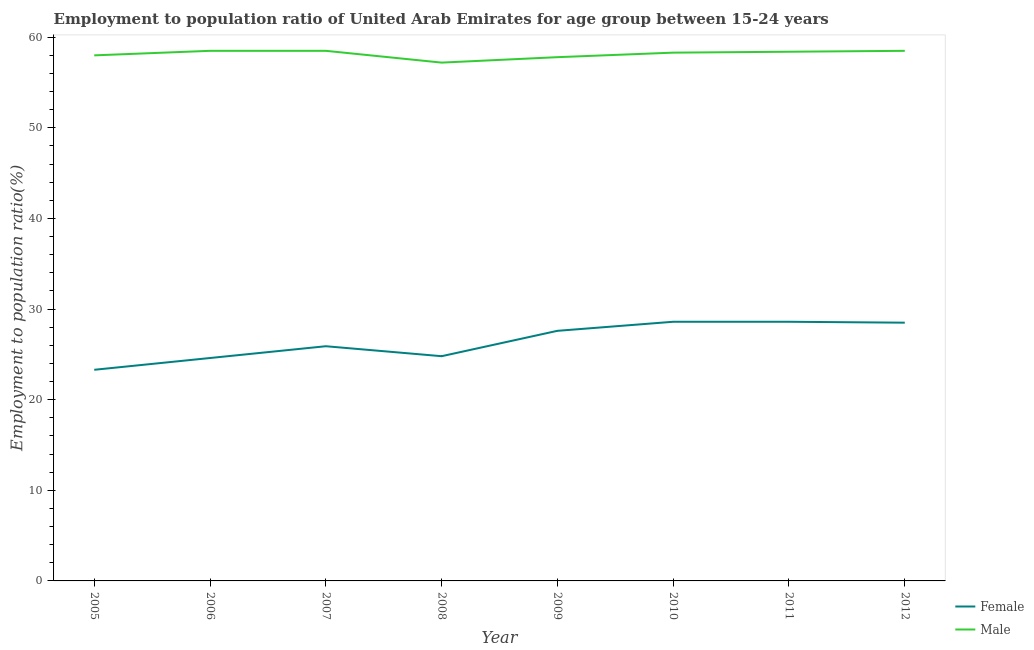How many different coloured lines are there?
Your answer should be very brief. 2. Does the line corresponding to employment to population ratio(female) intersect with the line corresponding to employment to population ratio(male)?
Make the answer very short. No. Across all years, what is the maximum employment to population ratio(male)?
Offer a terse response. 58.5. Across all years, what is the minimum employment to population ratio(female)?
Offer a terse response. 23.3. In which year was the employment to population ratio(male) minimum?
Ensure brevity in your answer.  2008. What is the total employment to population ratio(male) in the graph?
Make the answer very short. 465.2. What is the difference between the employment to population ratio(male) in 2009 and that in 2011?
Your answer should be compact. -0.6. What is the difference between the employment to population ratio(female) in 2006 and the employment to population ratio(male) in 2008?
Your answer should be compact. -32.6. What is the average employment to population ratio(female) per year?
Provide a short and direct response. 26.49. What is the ratio of the employment to population ratio(male) in 2008 to that in 2010?
Your answer should be compact. 0.98. Is the employment to population ratio(male) in 2010 less than that in 2012?
Provide a succinct answer. Yes. What is the difference between the highest and the lowest employment to population ratio(male)?
Keep it short and to the point. 1.3. In how many years, is the employment to population ratio(male) greater than the average employment to population ratio(male) taken over all years?
Offer a terse response. 5. Is the sum of the employment to population ratio(male) in 2009 and 2010 greater than the maximum employment to population ratio(female) across all years?
Your answer should be very brief. Yes. Does the employment to population ratio(female) monotonically increase over the years?
Your answer should be very brief. No. Is the employment to population ratio(male) strictly less than the employment to population ratio(female) over the years?
Make the answer very short. No. How many lines are there?
Your response must be concise. 2. How many years are there in the graph?
Offer a very short reply. 8. Does the graph contain grids?
Provide a short and direct response. No. How many legend labels are there?
Provide a short and direct response. 2. What is the title of the graph?
Your response must be concise. Employment to population ratio of United Arab Emirates for age group between 15-24 years. What is the label or title of the X-axis?
Provide a short and direct response. Year. What is the Employment to population ratio(%) of Female in 2005?
Your answer should be compact. 23.3. What is the Employment to population ratio(%) of Male in 2005?
Offer a terse response. 58. What is the Employment to population ratio(%) in Female in 2006?
Give a very brief answer. 24.6. What is the Employment to population ratio(%) in Male in 2006?
Make the answer very short. 58.5. What is the Employment to population ratio(%) in Female in 2007?
Provide a short and direct response. 25.9. What is the Employment to population ratio(%) in Male in 2007?
Your response must be concise. 58.5. What is the Employment to population ratio(%) of Female in 2008?
Provide a short and direct response. 24.8. What is the Employment to population ratio(%) of Male in 2008?
Offer a terse response. 57.2. What is the Employment to population ratio(%) in Female in 2009?
Provide a short and direct response. 27.6. What is the Employment to population ratio(%) of Male in 2009?
Your answer should be very brief. 57.8. What is the Employment to population ratio(%) of Female in 2010?
Make the answer very short. 28.6. What is the Employment to population ratio(%) in Male in 2010?
Give a very brief answer. 58.3. What is the Employment to population ratio(%) of Female in 2011?
Your answer should be compact. 28.6. What is the Employment to population ratio(%) in Male in 2011?
Provide a short and direct response. 58.4. What is the Employment to population ratio(%) of Female in 2012?
Provide a short and direct response. 28.5. What is the Employment to population ratio(%) in Male in 2012?
Your response must be concise. 58.5. Across all years, what is the maximum Employment to population ratio(%) in Female?
Make the answer very short. 28.6. Across all years, what is the maximum Employment to population ratio(%) of Male?
Ensure brevity in your answer.  58.5. Across all years, what is the minimum Employment to population ratio(%) in Female?
Make the answer very short. 23.3. Across all years, what is the minimum Employment to population ratio(%) in Male?
Offer a very short reply. 57.2. What is the total Employment to population ratio(%) of Female in the graph?
Provide a short and direct response. 211.9. What is the total Employment to population ratio(%) in Male in the graph?
Make the answer very short. 465.2. What is the difference between the Employment to population ratio(%) of Male in 2005 and that in 2006?
Give a very brief answer. -0.5. What is the difference between the Employment to population ratio(%) of Male in 2005 and that in 2007?
Your response must be concise. -0.5. What is the difference between the Employment to population ratio(%) of Female in 2005 and that in 2009?
Give a very brief answer. -4.3. What is the difference between the Employment to population ratio(%) in Male in 2005 and that in 2009?
Make the answer very short. 0.2. What is the difference between the Employment to population ratio(%) of Female in 2005 and that in 2010?
Provide a succinct answer. -5.3. What is the difference between the Employment to population ratio(%) of Female in 2005 and that in 2012?
Make the answer very short. -5.2. What is the difference between the Employment to population ratio(%) in Male in 2006 and that in 2007?
Give a very brief answer. 0. What is the difference between the Employment to population ratio(%) in Female in 2006 and that in 2010?
Make the answer very short. -4. What is the difference between the Employment to population ratio(%) in Male in 2006 and that in 2010?
Your response must be concise. 0.2. What is the difference between the Employment to population ratio(%) in Female in 2006 and that in 2011?
Offer a terse response. -4. What is the difference between the Employment to population ratio(%) in Male in 2006 and that in 2011?
Offer a very short reply. 0.1. What is the difference between the Employment to population ratio(%) of Female in 2007 and that in 2008?
Your response must be concise. 1.1. What is the difference between the Employment to population ratio(%) in Male in 2007 and that in 2008?
Offer a terse response. 1.3. What is the difference between the Employment to population ratio(%) of Male in 2007 and that in 2009?
Provide a succinct answer. 0.7. What is the difference between the Employment to population ratio(%) in Male in 2007 and that in 2011?
Ensure brevity in your answer.  0.1. What is the difference between the Employment to population ratio(%) of Female in 2008 and that in 2009?
Your response must be concise. -2.8. What is the difference between the Employment to population ratio(%) of Female in 2008 and that in 2010?
Provide a succinct answer. -3.8. What is the difference between the Employment to population ratio(%) in Male in 2008 and that in 2010?
Keep it short and to the point. -1.1. What is the difference between the Employment to population ratio(%) in Female in 2008 and that in 2011?
Keep it short and to the point. -3.8. What is the difference between the Employment to population ratio(%) in Female in 2008 and that in 2012?
Your answer should be compact. -3.7. What is the difference between the Employment to population ratio(%) of Female in 2009 and that in 2010?
Ensure brevity in your answer.  -1. What is the difference between the Employment to population ratio(%) of Female in 2009 and that in 2011?
Your answer should be compact. -1. What is the difference between the Employment to population ratio(%) in Male in 2009 and that in 2011?
Your response must be concise. -0.6. What is the difference between the Employment to population ratio(%) of Female in 2009 and that in 2012?
Ensure brevity in your answer.  -0.9. What is the difference between the Employment to population ratio(%) in Female in 2010 and that in 2011?
Your response must be concise. 0. What is the difference between the Employment to population ratio(%) in Female in 2010 and that in 2012?
Provide a short and direct response. 0.1. What is the difference between the Employment to population ratio(%) in Male in 2010 and that in 2012?
Provide a short and direct response. -0.2. What is the difference between the Employment to population ratio(%) of Female in 2011 and that in 2012?
Give a very brief answer. 0.1. What is the difference between the Employment to population ratio(%) of Male in 2011 and that in 2012?
Make the answer very short. -0.1. What is the difference between the Employment to population ratio(%) in Female in 2005 and the Employment to population ratio(%) in Male in 2006?
Make the answer very short. -35.2. What is the difference between the Employment to population ratio(%) of Female in 2005 and the Employment to population ratio(%) of Male in 2007?
Your response must be concise. -35.2. What is the difference between the Employment to population ratio(%) of Female in 2005 and the Employment to population ratio(%) of Male in 2008?
Offer a terse response. -33.9. What is the difference between the Employment to population ratio(%) of Female in 2005 and the Employment to population ratio(%) of Male in 2009?
Make the answer very short. -34.5. What is the difference between the Employment to population ratio(%) of Female in 2005 and the Employment to population ratio(%) of Male in 2010?
Give a very brief answer. -35. What is the difference between the Employment to population ratio(%) in Female in 2005 and the Employment to population ratio(%) in Male in 2011?
Give a very brief answer. -35.1. What is the difference between the Employment to population ratio(%) in Female in 2005 and the Employment to population ratio(%) in Male in 2012?
Give a very brief answer. -35.2. What is the difference between the Employment to population ratio(%) in Female in 2006 and the Employment to population ratio(%) in Male in 2007?
Make the answer very short. -33.9. What is the difference between the Employment to population ratio(%) in Female in 2006 and the Employment to population ratio(%) in Male in 2008?
Make the answer very short. -32.6. What is the difference between the Employment to population ratio(%) of Female in 2006 and the Employment to population ratio(%) of Male in 2009?
Offer a terse response. -33.2. What is the difference between the Employment to population ratio(%) of Female in 2006 and the Employment to population ratio(%) of Male in 2010?
Ensure brevity in your answer.  -33.7. What is the difference between the Employment to population ratio(%) of Female in 2006 and the Employment to population ratio(%) of Male in 2011?
Give a very brief answer. -33.8. What is the difference between the Employment to population ratio(%) in Female in 2006 and the Employment to population ratio(%) in Male in 2012?
Offer a terse response. -33.9. What is the difference between the Employment to population ratio(%) of Female in 2007 and the Employment to population ratio(%) of Male in 2008?
Offer a very short reply. -31.3. What is the difference between the Employment to population ratio(%) of Female in 2007 and the Employment to population ratio(%) of Male in 2009?
Give a very brief answer. -31.9. What is the difference between the Employment to population ratio(%) in Female in 2007 and the Employment to population ratio(%) in Male in 2010?
Keep it short and to the point. -32.4. What is the difference between the Employment to population ratio(%) of Female in 2007 and the Employment to population ratio(%) of Male in 2011?
Offer a terse response. -32.5. What is the difference between the Employment to population ratio(%) of Female in 2007 and the Employment to population ratio(%) of Male in 2012?
Your answer should be compact. -32.6. What is the difference between the Employment to population ratio(%) in Female in 2008 and the Employment to population ratio(%) in Male in 2009?
Ensure brevity in your answer.  -33. What is the difference between the Employment to population ratio(%) in Female in 2008 and the Employment to population ratio(%) in Male in 2010?
Make the answer very short. -33.5. What is the difference between the Employment to population ratio(%) in Female in 2008 and the Employment to population ratio(%) in Male in 2011?
Offer a terse response. -33.6. What is the difference between the Employment to population ratio(%) in Female in 2008 and the Employment to population ratio(%) in Male in 2012?
Your answer should be compact. -33.7. What is the difference between the Employment to population ratio(%) in Female in 2009 and the Employment to population ratio(%) in Male in 2010?
Give a very brief answer. -30.7. What is the difference between the Employment to population ratio(%) in Female in 2009 and the Employment to population ratio(%) in Male in 2011?
Your answer should be very brief. -30.8. What is the difference between the Employment to population ratio(%) in Female in 2009 and the Employment to population ratio(%) in Male in 2012?
Offer a terse response. -30.9. What is the difference between the Employment to population ratio(%) in Female in 2010 and the Employment to population ratio(%) in Male in 2011?
Provide a succinct answer. -29.8. What is the difference between the Employment to population ratio(%) in Female in 2010 and the Employment to population ratio(%) in Male in 2012?
Provide a succinct answer. -29.9. What is the difference between the Employment to population ratio(%) of Female in 2011 and the Employment to population ratio(%) of Male in 2012?
Give a very brief answer. -29.9. What is the average Employment to population ratio(%) of Female per year?
Offer a terse response. 26.49. What is the average Employment to population ratio(%) in Male per year?
Ensure brevity in your answer.  58.15. In the year 2005, what is the difference between the Employment to population ratio(%) in Female and Employment to population ratio(%) in Male?
Give a very brief answer. -34.7. In the year 2006, what is the difference between the Employment to population ratio(%) of Female and Employment to population ratio(%) of Male?
Your answer should be compact. -33.9. In the year 2007, what is the difference between the Employment to population ratio(%) of Female and Employment to population ratio(%) of Male?
Offer a very short reply. -32.6. In the year 2008, what is the difference between the Employment to population ratio(%) in Female and Employment to population ratio(%) in Male?
Give a very brief answer. -32.4. In the year 2009, what is the difference between the Employment to population ratio(%) in Female and Employment to population ratio(%) in Male?
Your answer should be compact. -30.2. In the year 2010, what is the difference between the Employment to population ratio(%) in Female and Employment to population ratio(%) in Male?
Your answer should be compact. -29.7. In the year 2011, what is the difference between the Employment to population ratio(%) of Female and Employment to population ratio(%) of Male?
Keep it short and to the point. -29.8. What is the ratio of the Employment to population ratio(%) in Female in 2005 to that in 2006?
Give a very brief answer. 0.95. What is the ratio of the Employment to population ratio(%) of Female in 2005 to that in 2007?
Provide a succinct answer. 0.9. What is the ratio of the Employment to population ratio(%) of Female in 2005 to that in 2008?
Your answer should be very brief. 0.94. What is the ratio of the Employment to population ratio(%) in Male in 2005 to that in 2008?
Offer a very short reply. 1.01. What is the ratio of the Employment to population ratio(%) of Female in 2005 to that in 2009?
Give a very brief answer. 0.84. What is the ratio of the Employment to population ratio(%) in Female in 2005 to that in 2010?
Ensure brevity in your answer.  0.81. What is the ratio of the Employment to population ratio(%) of Male in 2005 to that in 2010?
Provide a short and direct response. 0.99. What is the ratio of the Employment to population ratio(%) of Female in 2005 to that in 2011?
Keep it short and to the point. 0.81. What is the ratio of the Employment to population ratio(%) of Male in 2005 to that in 2011?
Your answer should be compact. 0.99. What is the ratio of the Employment to population ratio(%) in Female in 2005 to that in 2012?
Offer a very short reply. 0.82. What is the ratio of the Employment to population ratio(%) of Female in 2006 to that in 2007?
Offer a very short reply. 0.95. What is the ratio of the Employment to population ratio(%) in Male in 2006 to that in 2007?
Ensure brevity in your answer.  1. What is the ratio of the Employment to population ratio(%) of Female in 2006 to that in 2008?
Provide a succinct answer. 0.99. What is the ratio of the Employment to population ratio(%) of Male in 2006 to that in 2008?
Make the answer very short. 1.02. What is the ratio of the Employment to population ratio(%) in Female in 2006 to that in 2009?
Provide a succinct answer. 0.89. What is the ratio of the Employment to population ratio(%) in Male in 2006 to that in 2009?
Your answer should be very brief. 1.01. What is the ratio of the Employment to population ratio(%) of Female in 2006 to that in 2010?
Give a very brief answer. 0.86. What is the ratio of the Employment to population ratio(%) of Female in 2006 to that in 2011?
Offer a very short reply. 0.86. What is the ratio of the Employment to population ratio(%) in Female in 2006 to that in 2012?
Provide a succinct answer. 0.86. What is the ratio of the Employment to population ratio(%) of Male in 2006 to that in 2012?
Provide a succinct answer. 1. What is the ratio of the Employment to population ratio(%) in Female in 2007 to that in 2008?
Offer a terse response. 1.04. What is the ratio of the Employment to population ratio(%) of Male in 2007 to that in 2008?
Offer a terse response. 1.02. What is the ratio of the Employment to population ratio(%) of Female in 2007 to that in 2009?
Ensure brevity in your answer.  0.94. What is the ratio of the Employment to population ratio(%) of Male in 2007 to that in 2009?
Keep it short and to the point. 1.01. What is the ratio of the Employment to population ratio(%) of Female in 2007 to that in 2010?
Ensure brevity in your answer.  0.91. What is the ratio of the Employment to population ratio(%) in Female in 2007 to that in 2011?
Your response must be concise. 0.91. What is the ratio of the Employment to population ratio(%) of Female in 2007 to that in 2012?
Keep it short and to the point. 0.91. What is the ratio of the Employment to population ratio(%) in Female in 2008 to that in 2009?
Keep it short and to the point. 0.9. What is the ratio of the Employment to population ratio(%) in Male in 2008 to that in 2009?
Provide a succinct answer. 0.99. What is the ratio of the Employment to population ratio(%) in Female in 2008 to that in 2010?
Provide a short and direct response. 0.87. What is the ratio of the Employment to population ratio(%) in Male in 2008 to that in 2010?
Provide a short and direct response. 0.98. What is the ratio of the Employment to population ratio(%) in Female in 2008 to that in 2011?
Provide a succinct answer. 0.87. What is the ratio of the Employment to population ratio(%) in Male in 2008 to that in 2011?
Your answer should be compact. 0.98. What is the ratio of the Employment to population ratio(%) in Female in 2008 to that in 2012?
Your answer should be very brief. 0.87. What is the ratio of the Employment to population ratio(%) in Male in 2008 to that in 2012?
Ensure brevity in your answer.  0.98. What is the ratio of the Employment to population ratio(%) of Female in 2009 to that in 2010?
Ensure brevity in your answer.  0.96. What is the ratio of the Employment to population ratio(%) of Male in 2009 to that in 2010?
Provide a short and direct response. 0.99. What is the ratio of the Employment to population ratio(%) of Male in 2009 to that in 2011?
Ensure brevity in your answer.  0.99. What is the ratio of the Employment to population ratio(%) of Female in 2009 to that in 2012?
Provide a succinct answer. 0.97. What is the ratio of the Employment to population ratio(%) of Female in 2010 to that in 2011?
Provide a succinct answer. 1. What is the ratio of the Employment to population ratio(%) of Male in 2010 to that in 2011?
Make the answer very short. 1. What is the ratio of the Employment to population ratio(%) in Male in 2011 to that in 2012?
Make the answer very short. 1. What is the difference between the highest and the second highest Employment to population ratio(%) in Male?
Provide a short and direct response. 0. What is the difference between the highest and the lowest Employment to population ratio(%) in Female?
Your answer should be very brief. 5.3. What is the difference between the highest and the lowest Employment to population ratio(%) of Male?
Your answer should be very brief. 1.3. 